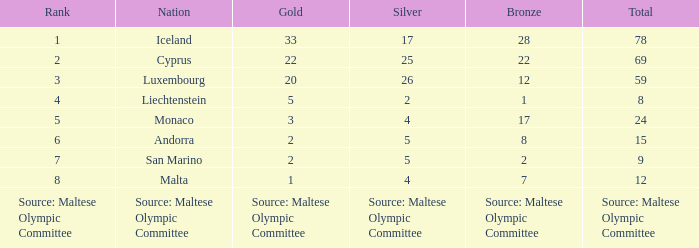How many bronze medals are owned by the number 1 ranked nation? 28.0. 